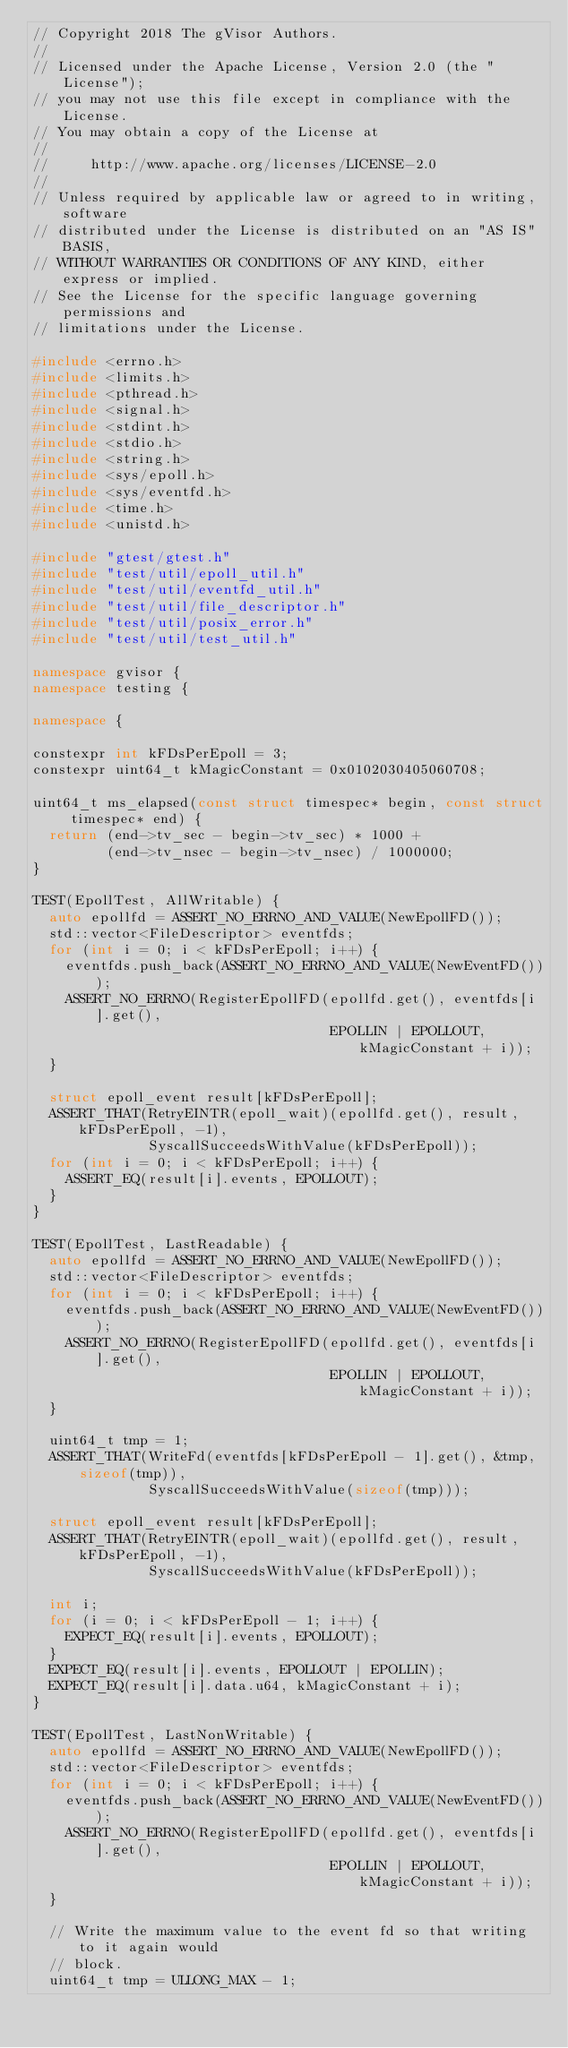<code> <loc_0><loc_0><loc_500><loc_500><_C++_>// Copyright 2018 The gVisor Authors.
//
// Licensed under the Apache License, Version 2.0 (the "License");
// you may not use this file except in compliance with the License.
// You may obtain a copy of the License at
//
//     http://www.apache.org/licenses/LICENSE-2.0
//
// Unless required by applicable law or agreed to in writing, software
// distributed under the License is distributed on an "AS IS" BASIS,
// WITHOUT WARRANTIES OR CONDITIONS OF ANY KIND, either express or implied.
// See the License for the specific language governing permissions and
// limitations under the License.

#include <errno.h>
#include <limits.h>
#include <pthread.h>
#include <signal.h>
#include <stdint.h>
#include <stdio.h>
#include <string.h>
#include <sys/epoll.h>
#include <sys/eventfd.h>
#include <time.h>
#include <unistd.h>

#include "gtest/gtest.h"
#include "test/util/epoll_util.h"
#include "test/util/eventfd_util.h"
#include "test/util/file_descriptor.h"
#include "test/util/posix_error.h"
#include "test/util/test_util.h"

namespace gvisor {
namespace testing {

namespace {

constexpr int kFDsPerEpoll = 3;
constexpr uint64_t kMagicConstant = 0x0102030405060708;

uint64_t ms_elapsed(const struct timespec* begin, const struct timespec* end) {
  return (end->tv_sec - begin->tv_sec) * 1000 +
         (end->tv_nsec - begin->tv_nsec) / 1000000;
}

TEST(EpollTest, AllWritable) {
  auto epollfd = ASSERT_NO_ERRNO_AND_VALUE(NewEpollFD());
  std::vector<FileDescriptor> eventfds;
  for (int i = 0; i < kFDsPerEpoll; i++) {
    eventfds.push_back(ASSERT_NO_ERRNO_AND_VALUE(NewEventFD()));
    ASSERT_NO_ERRNO(RegisterEpollFD(epollfd.get(), eventfds[i].get(),
                                    EPOLLIN | EPOLLOUT, kMagicConstant + i));
  }

  struct epoll_event result[kFDsPerEpoll];
  ASSERT_THAT(RetryEINTR(epoll_wait)(epollfd.get(), result, kFDsPerEpoll, -1),
              SyscallSucceedsWithValue(kFDsPerEpoll));
  for (int i = 0; i < kFDsPerEpoll; i++) {
    ASSERT_EQ(result[i].events, EPOLLOUT);
  }
}

TEST(EpollTest, LastReadable) {
  auto epollfd = ASSERT_NO_ERRNO_AND_VALUE(NewEpollFD());
  std::vector<FileDescriptor> eventfds;
  for (int i = 0; i < kFDsPerEpoll; i++) {
    eventfds.push_back(ASSERT_NO_ERRNO_AND_VALUE(NewEventFD()));
    ASSERT_NO_ERRNO(RegisterEpollFD(epollfd.get(), eventfds[i].get(),
                                    EPOLLIN | EPOLLOUT, kMagicConstant + i));
  }

  uint64_t tmp = 1;
  ASSERT_THAT(WriteFd(eventfds[kFDsPerEpoll - 1].get(), &tmp, sizeof(tmp)),
              SyscallSucceedsWithValue(sizeof(tmp)));

  struct epoll_event result[kFDsPerEpoll];
  ASSERT_THAT(RetryEINTR(epoll_wait)(epollfd.get(), result, kFDsPerEpoll, -1),
              SyscallSucceedsWithValue(kFDsPerEpoll));

  int i;
  for (i = 0; i < kFDsPerEpoll - 1; i++) {
    EXPECT_EQ(result[i].events, EPOLLOUT);
  }
  EXPECT_EQ(result[i].events, EPOLLOUT | EPOLLIN);
  EXPECT_EQ(result[i].data.u64, kMagicConstant + i);
}

TEST(EpollTest, LastNonWritable) {
  auto epollfd = ASSERT_NO_ERRNO_AND_VALUE(NewEpollFD());
  std::vector<FileDescriptor> eventfds;
  for (int i = 0; i < kFDsPerEpoll; i++) {
    eventfds.push_back(ASSERT_NO_ERRNO_AND_VALUE(NewEventFD()));
    ASSERT_NO_ERRNO(RegisterEpollFD(epollfd.get(), eventfds[i].get(),
                                    EPOLLIN | EPOLLOUT, kMagicConstant + i));
  }

  // Write the maximum value to the event fd so that writing to it again would
  // block.
  uint64_t tmp = ULLONG_MAX - 1;</code> 